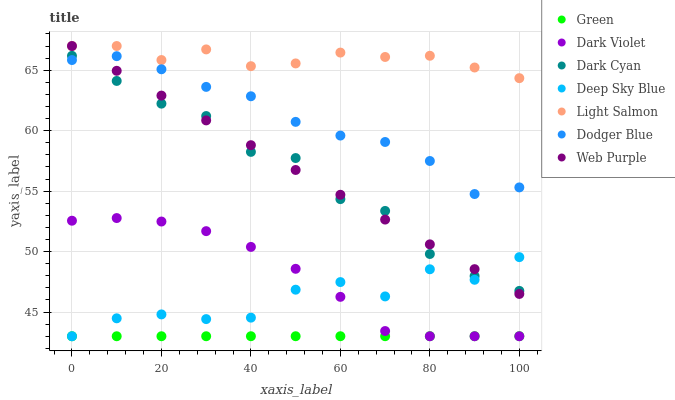Does Green have the minimum area under the curve?
Answer yes or no. Yes. Does Light Salmon have the maximum area under the curve?
Answer yes or no. Yes. Does Dark Violet have the minimum area under the curve?
Answer yes or no. No. Does Dark Violet have the maximum area under the curve?
Answer yes or no. No. Is Web Purple the smoothest?
Answer yes or no. Yes. Is Deep Sky Blue the roughest?
Answer yes or no. Yes. Is Dark Violet the smoothest?
Answer yes or no. No. Is Dark Violet the roughest?
Answer yes or no. No. Does Dark Violet have the lowest value?
Answer yes or no. Yes. Does Web Purple have the lowest value?
Answer yes or no. No. Does Web Purple have the highest value?
Answer yes or no. Yes. Does Dark Violet have the highest value?
Answer yes or no. No. Is Dark Violet less than Dodger Blue?
Answer yes or no. Yes. Is Web Purple greater than Dark Violet?
Answer yes or no. Yes. Does Dark Cyan intersect Dodger Blue?
Answer yes or no. Yes. Is Dark Cyan less than Dodger Blue?
Answer yes or no. No. Is Dark Cyan greater than Dodger Blue?
Answer yes or no. No. Does Dark Violet intersect Dodger Blue?
Answer yes or no. No. 